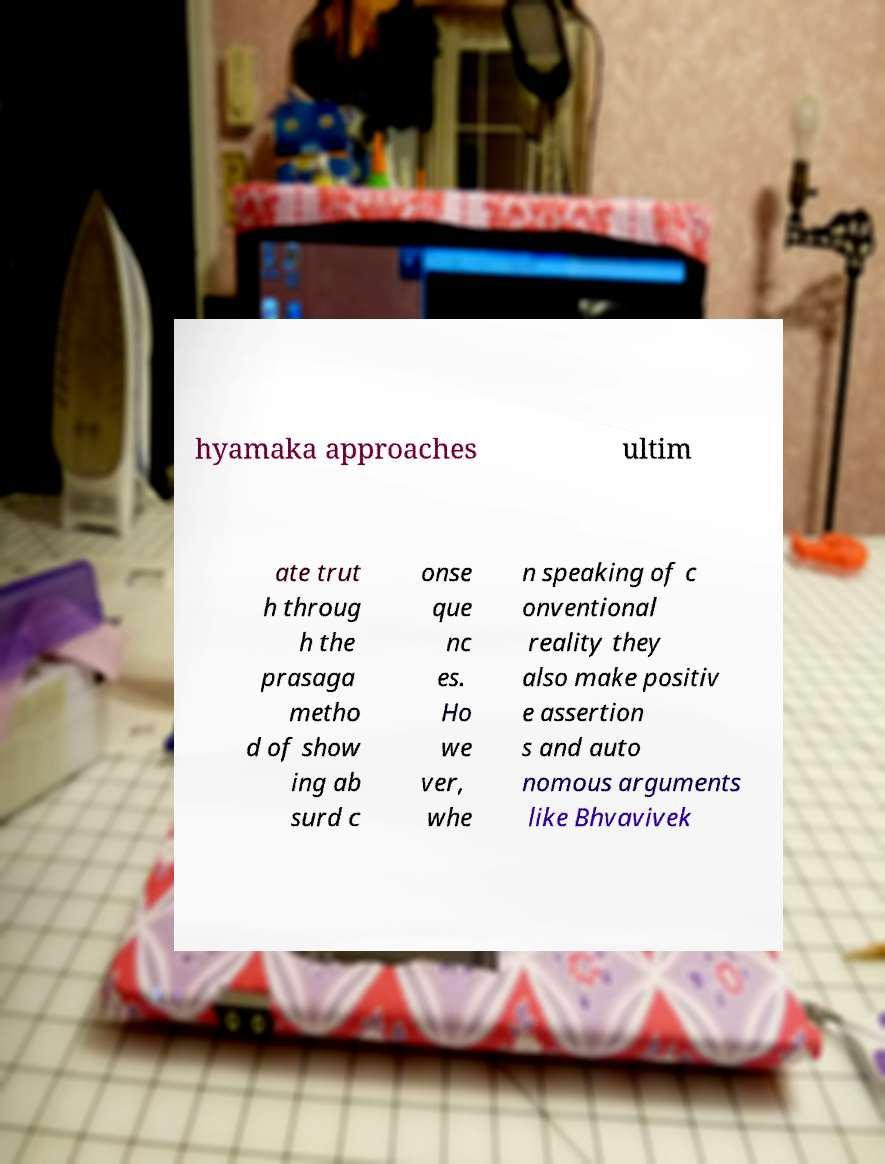What messages or text are displayed in this image? I need them in a readable, typed format. hyamaka approaches ultim ate trut h throug h the prasaga metho d of show ing ab surd c onse que nc es. Ho we ver, whe n speaking of c onventional reality they also make positiv e assertion s and auto nomous arguments like Bhvavivek 